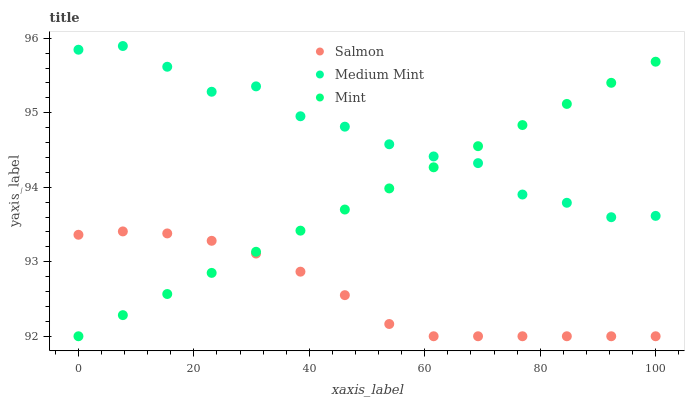Does Salmon have the minimum area under the curve?
Answer yes or no. Yes. Does Medium Mint have the maximum area under the curve?
Answer yes or no. Yes. Does Mint have the minimum area under the curve?
Answer yes or no. No. Does Mint have the maximum area under the curve?
Answer yes or no. No. Is Mint the smoothest?
Answer yes or no. Yes. Is Medium Mint the roughest?
Answer yes or no. Yes. Is Salmon the smoothest?
Answer yes or no. No. Is Salmon the roughest?
Answer yes or no. No. Does Mint have the lowest value?
Answer yes or no. Yes. Does Medium Mint have the highest value?
Answer yes or no. Yes. Does Mint have the highest value?
Answer yes or no. No. Is Salmon less than Medium Mint?
Answer yes or no. Yes. Is Medium Mint greater than Salmon?
Answer yes or no. Yes. Does Salmon intersect Mint?
Answer yes or no. Yes. Is Salmon less than Mint?
Answer yes or no. No. Is Salmon greater than Mint?
Answer yes or no. No. Does Salmon intersect Medium Mint?
Answer yes or no. No. 